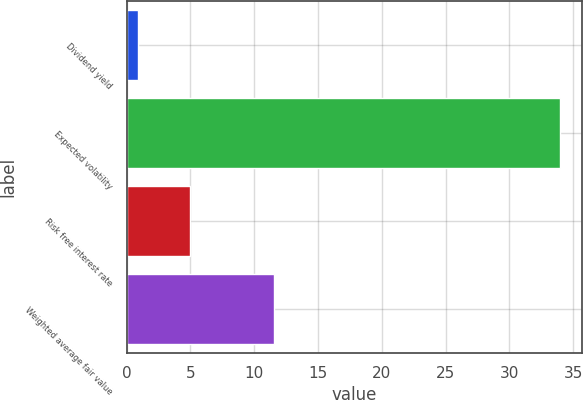Convert chart to OTSL. <chart><loc_0><loc_0><loc_500><loc_500><bar_chart><fcel>Dividend yield<fcel>Expected volatility<fcel>Risk free interest rate<fcel>Weighted average fair value<nl><fcel>0.9<fcel>34<fcel>5<fcel>11.52<nl></chart> 